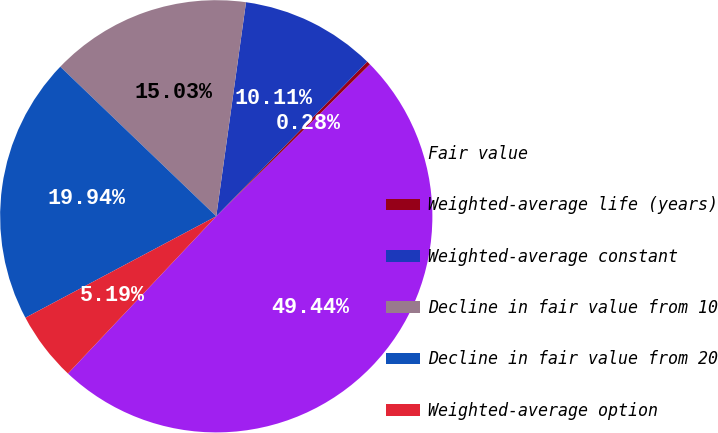Convert chart. <chart><loc_0><loc_0><loc_500><loc_500><pie_chart><fcel>Fair value<fcel>Weighted-average life (years)<fcel>Weighted-average constant<fcel>Decline in fair value from 10<fcel>Decline in fair value from 20<fcel>Weighted-average option<nl><fcel>49.44%<fcel>0.28%<fcel>10.11%<fcel>15.03%<fcel>19.94%<fcel>5.19%<nl></chart> 